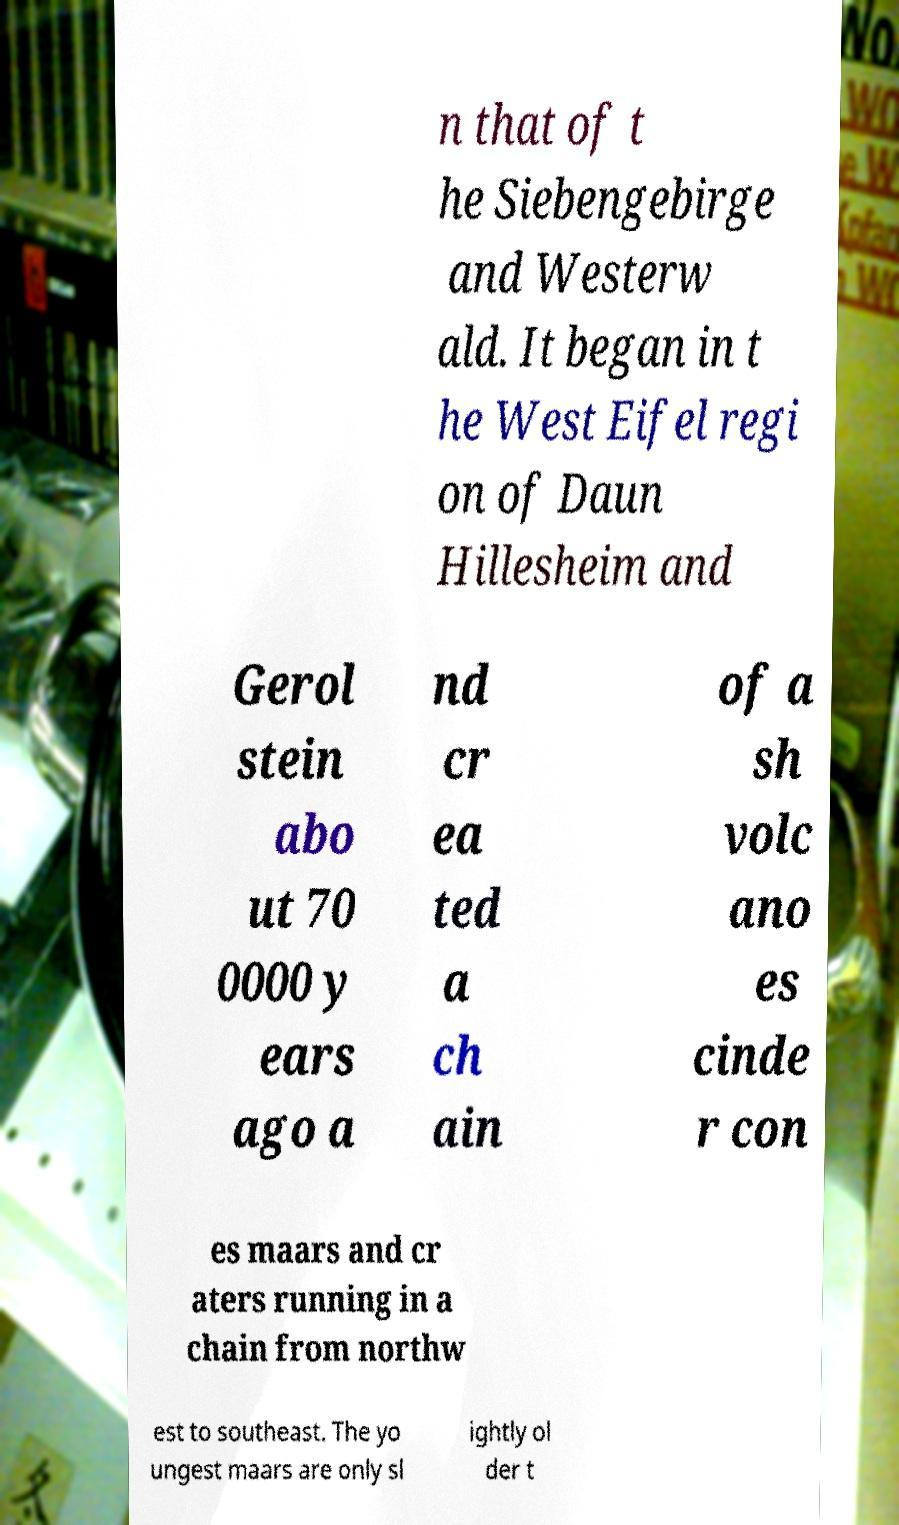Could you extract and type out the text from this image? n that of t he Siebengebirge and Westerw ald. It began in t he West Eifel regi on of Daun Hillesheim and Gerol stein abo ut 70 0000 y ears ago a nd cr ea ted a ch ain of a sh volc ano es cinde r con es maars and cr aters running in a chain from northw est to southeast. The yo ungest maars are only sl ightly ol der t 